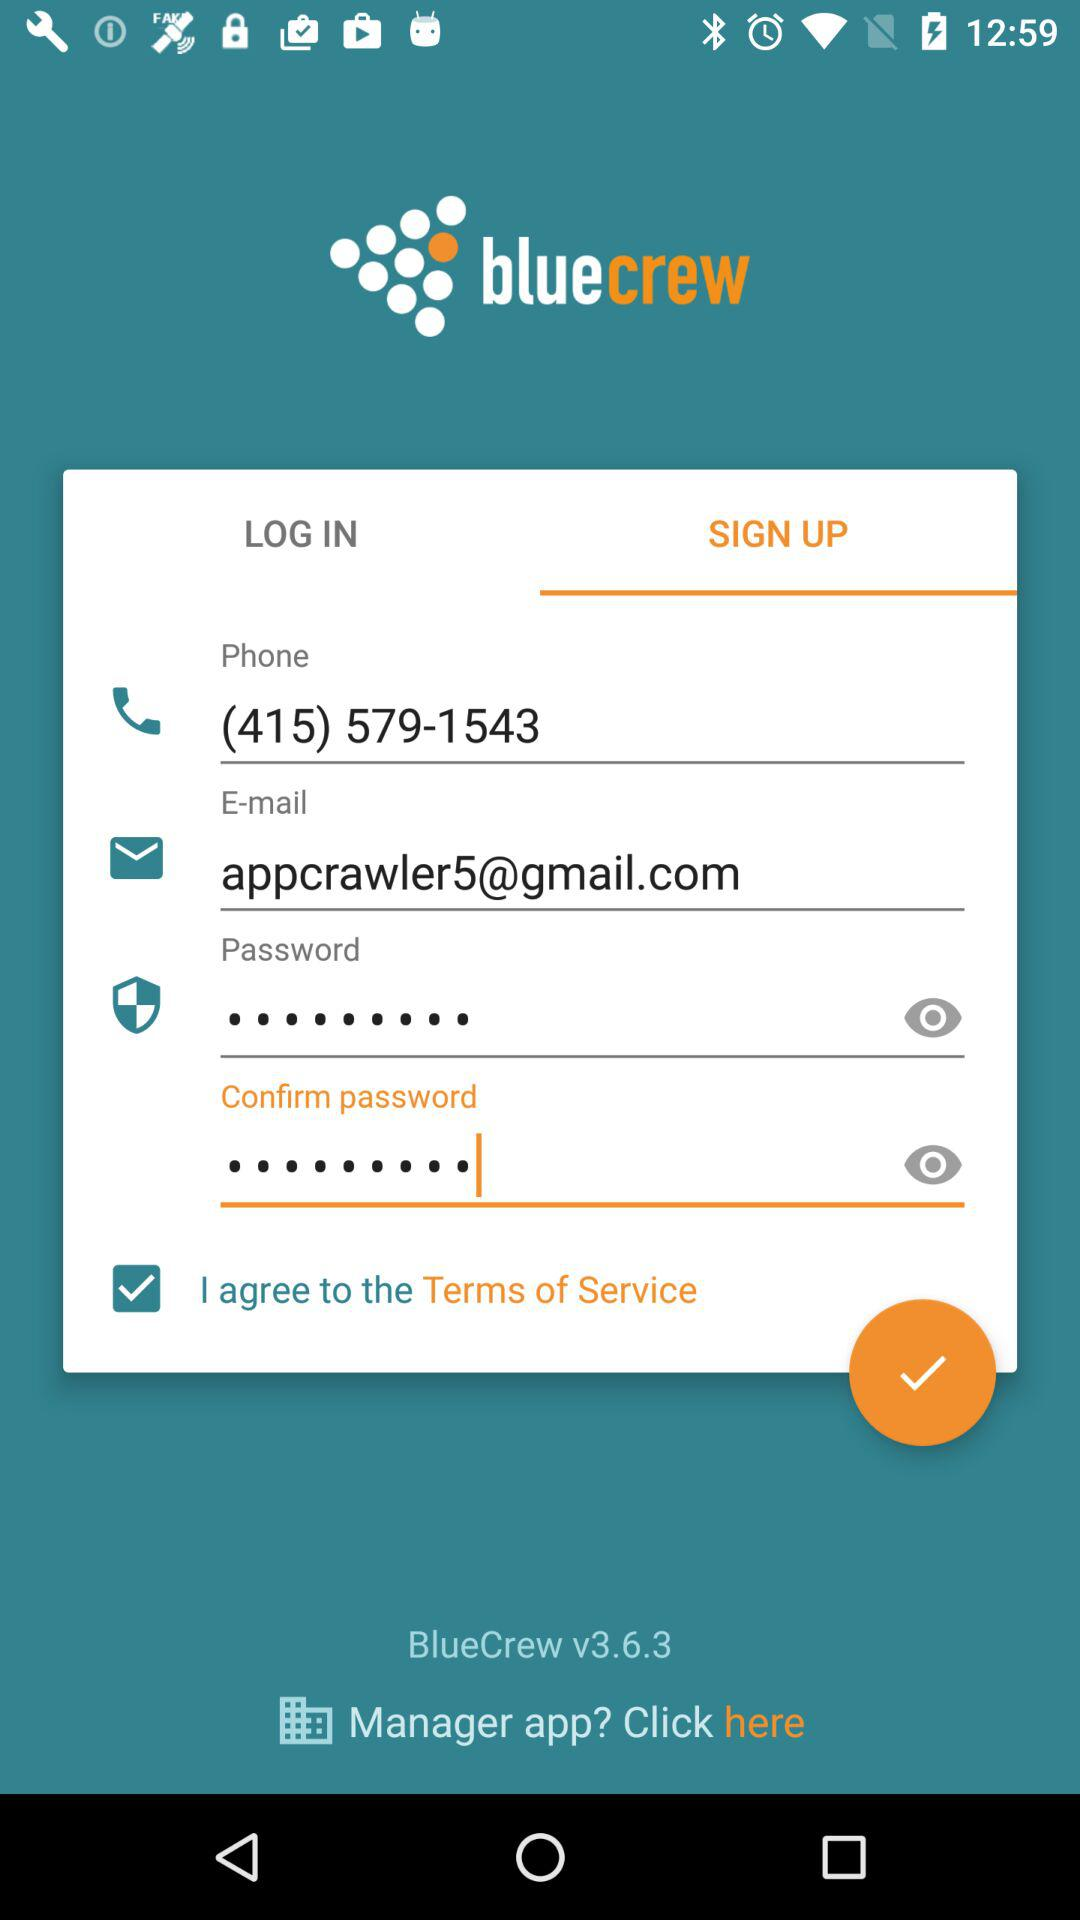What is the phone number? The phone number is (415) 579-1543. 